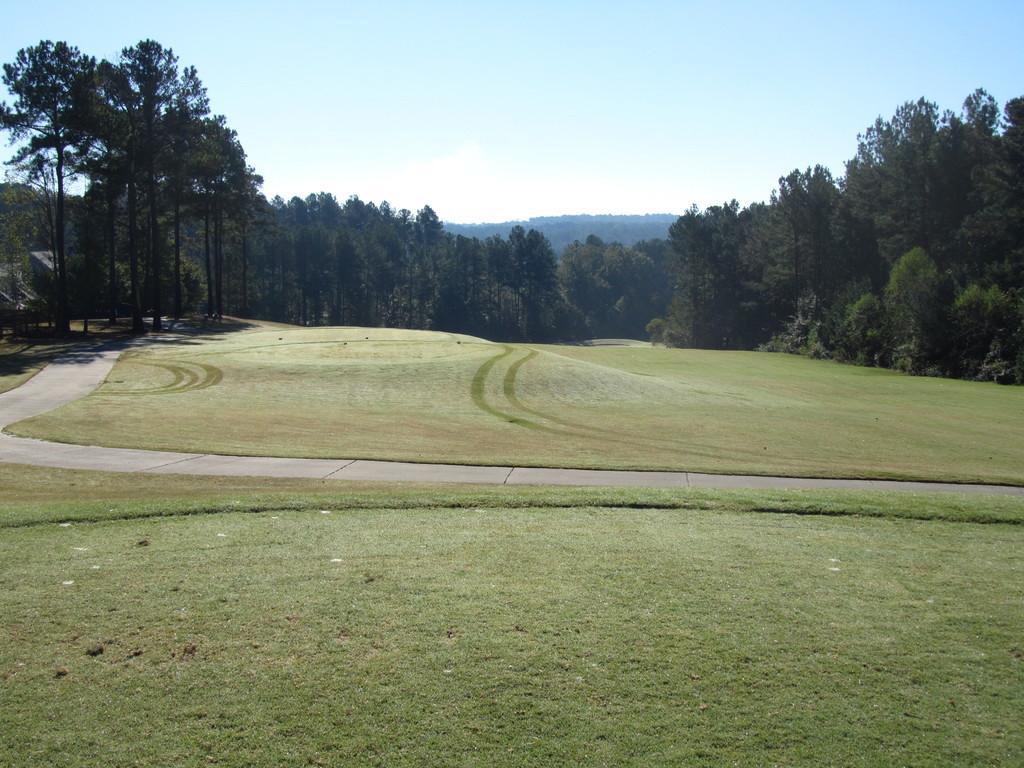Could you give a brief overview of what you see in this image? In front of the image there is a road, besides the road there is grass, in the background of the image there are trees and mountains. 